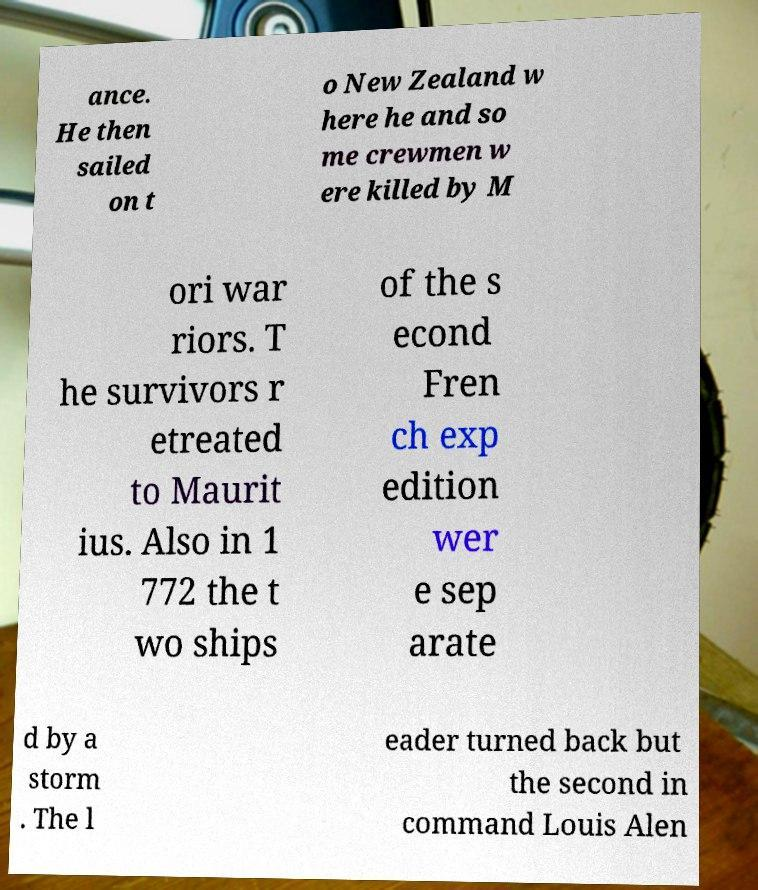Could you assist in decoding the text presented in this image and type it out clearly? ance. He then sailed on t o New Zealand w here he and so me crewmen w ere killed by M ori war riors. T he survivors r etreated to Maurit ius. Also in 1 772 the t wo ships of the s econd Fren ch exp edition wer e sep arate d by a storm . The l eader turned back but the second in command Louis Alen 